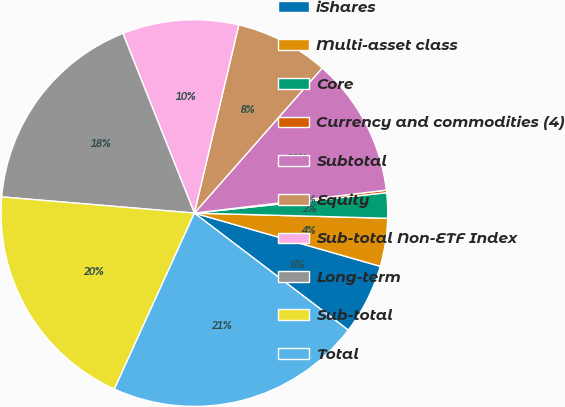Convert chart. <chart><loc_0><loc_0><loc_500><loc_500><pie_chart><fcel>iShares<fcel>Multi-asset class<fcel>Core<fcel>Currency and commodities (4)<fcel>Subtotal<fcel>Equity<fcel>Sub-total Non-ETF Index<fcel>Long-term<fcel>Sub-total<fcel>Total<nl><fcel>5.91%<fcel>4.01%<fcel>2.11%<fcel>0.21%<fcel>11.61%<fcel>7.81%<fcel>9.71%<fcel>17.64%<fcel>19.54%<fcel>21.44%<nl></chart> 